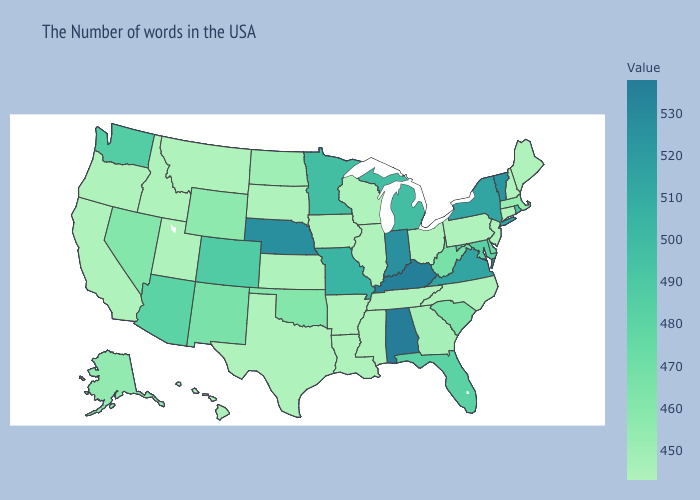Does Idaho have the lowest value in the West?
Short answer required. Yes. Among the states that border Maine , which have the highest value?
Answer briefly. New Hampshire. Does Nebraska have the highest value in the MidWest?
Answer briefly. Yes. Which states have the lowest value in the USA?
Write a very short answer. Maine, New Hampshire, Connecticut, New Jersey, Pennsylvania, North Carolina, Ohio, Tennessee, Wisconsin, Illinois, Mississippi, Louisiana, Arkansas, Iowa, Kansas, Texas, South Dakota, Utah, Montana, Idaho, California, Oregon. Does North Carolina have the lowest value in the South?
Give a very brief answer. Yes. 